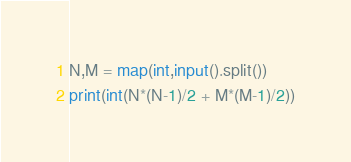<code> <loc_0><loc_0><loc_500><loc_500><_Python_>N,M = map(int,input().split())
print(int(N*(N-1)/2 + M*(M-1)/2))</code> 